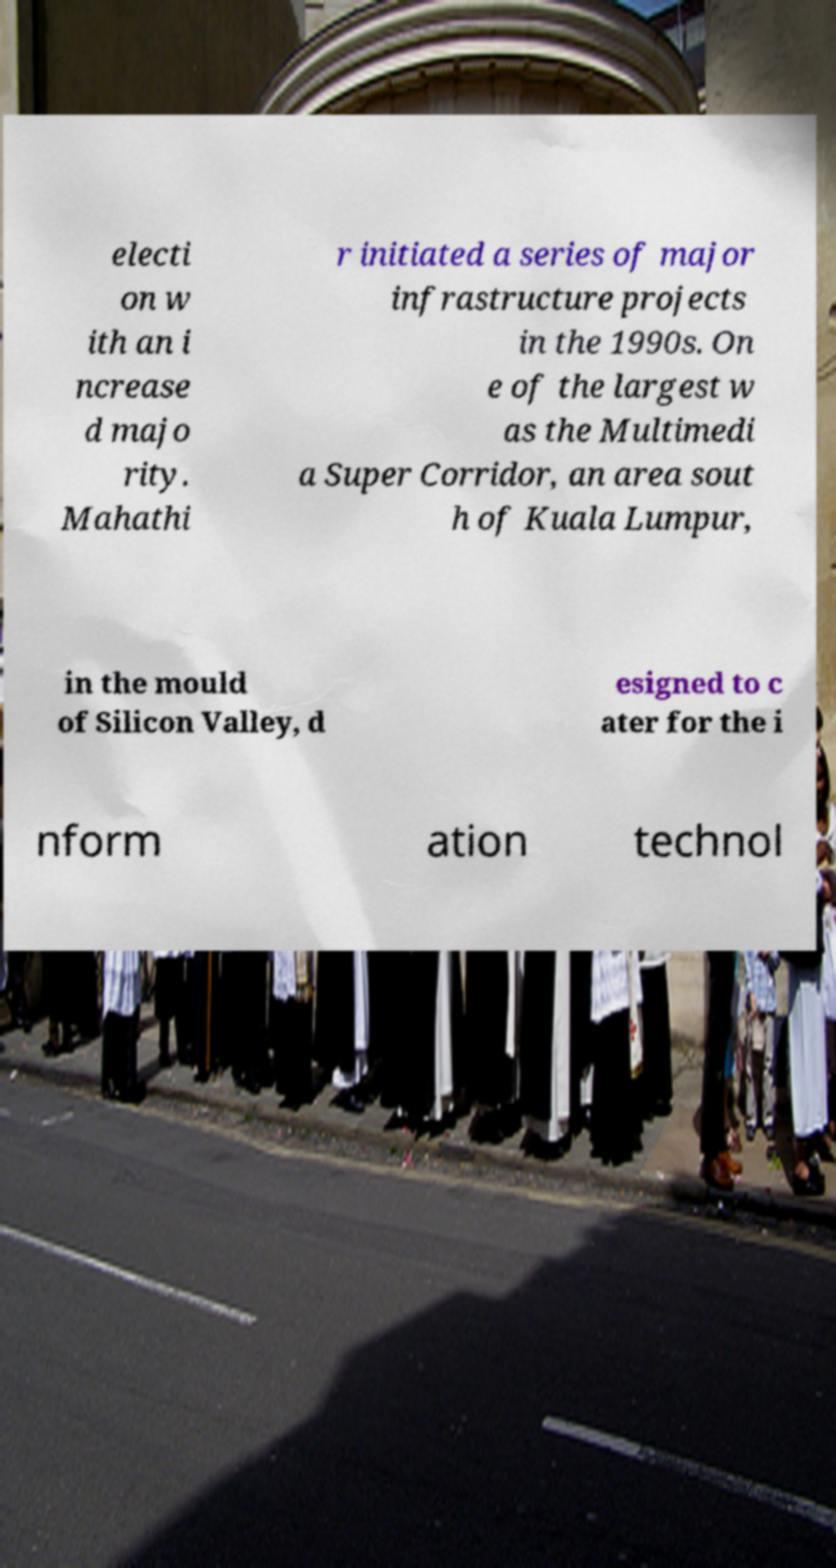Can you read and provide the text displayed in the image?This photo seems to have some interesting text. Can you extract and type it out for me? electi on w ith an i ncrease d majo rity. Mahathi r initiated a series of major infrastructure projects in the 1990s. On e of the largest w as the Multimedi a Super Corridor, an area sout h of Kuala Lumpur, in the mould of Silicon Valley, d esigned to c ater for the i nform ation technol 